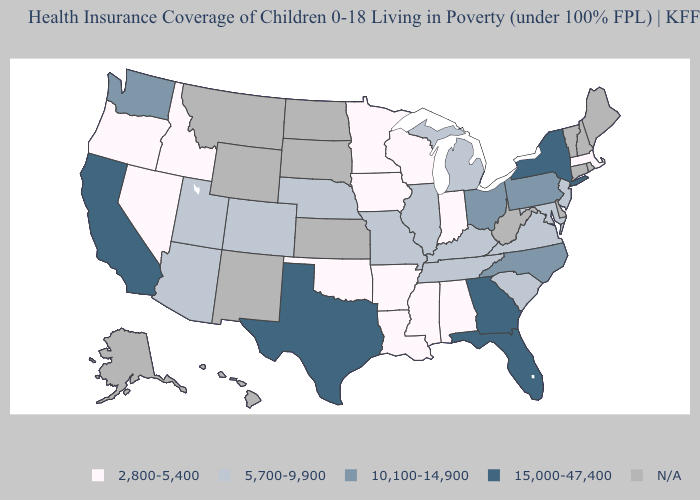What is the value of Iowa?
Be succinct. 2,800-5,400. What is the highest value in states that border Arkansas?
Write a very short answer. 15,000-47,400. How many symbols are there in the legend?
Short answer required. 5. Name the states that have a value in the range 10,100-14,900?
Give a very brief answer. North Carolina, Ohio, Pennsylvania, Washington. What is the value of Maine?
Give a very brief answer. N/A. Does the first symbol in the legend represent the smallest category?
Keep it brief. Yes. Among the states that border Montana , which have the highest value?
Give a very brief answer. Idaho. Name the states that have a value in the range 5,700-9,900?
Be succinct. Arizona, Colorado, Illinois, Kentucky, Maryland, Michigan, Missouri, Nebraska, New Jersey, South Carolina, Tennessee, Utah, Virginia. Name the states that have a value in the range 2,800-5,400?
Write a very short answer. Alabama, Arkansas, Idaho, Indiana, Iowa, Louisiana, Massachusetts, Minnesota, Mississippi, Nevada, Oklahoma, Oregon, Wisconsin. What is the value of Missouri?
Write a very short answer. 5,700-9,900. What is the value of Wyoming?
Write a very short answer. N/A. Does Georgia have the highest value in the USA?
Be succinct. Yes. Does Ohio have the lowest value in the MidWest?
Quick response, please. No. 